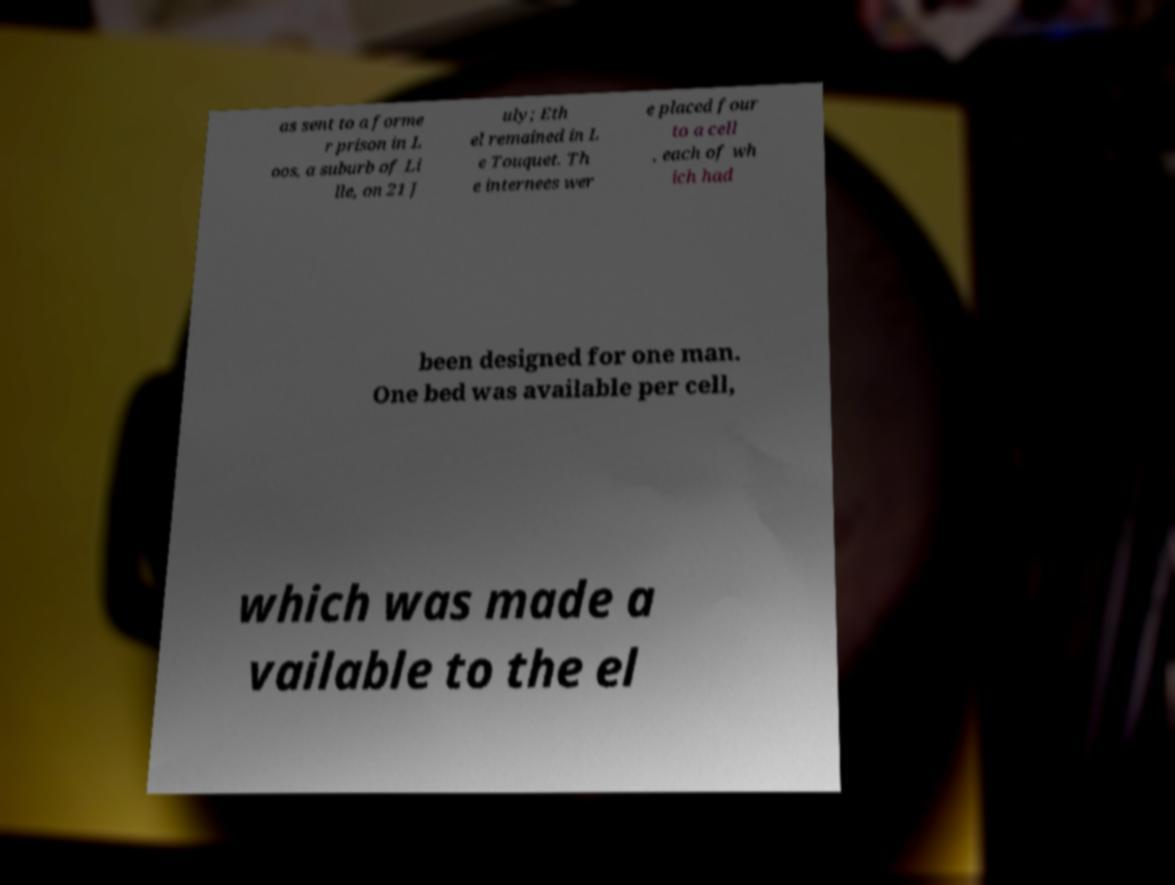Could you assist in decoding the text presented in this image and type it out clearly? as sent to a forme r prison in L oos, a suburb of Li lle, on 21 J uly; Eth el remained in L e Touquet. Th e internees wer e placed four to a cell , each of wh ich had been designed for one man. One bed was available per cell, which was made a vailable to the el 